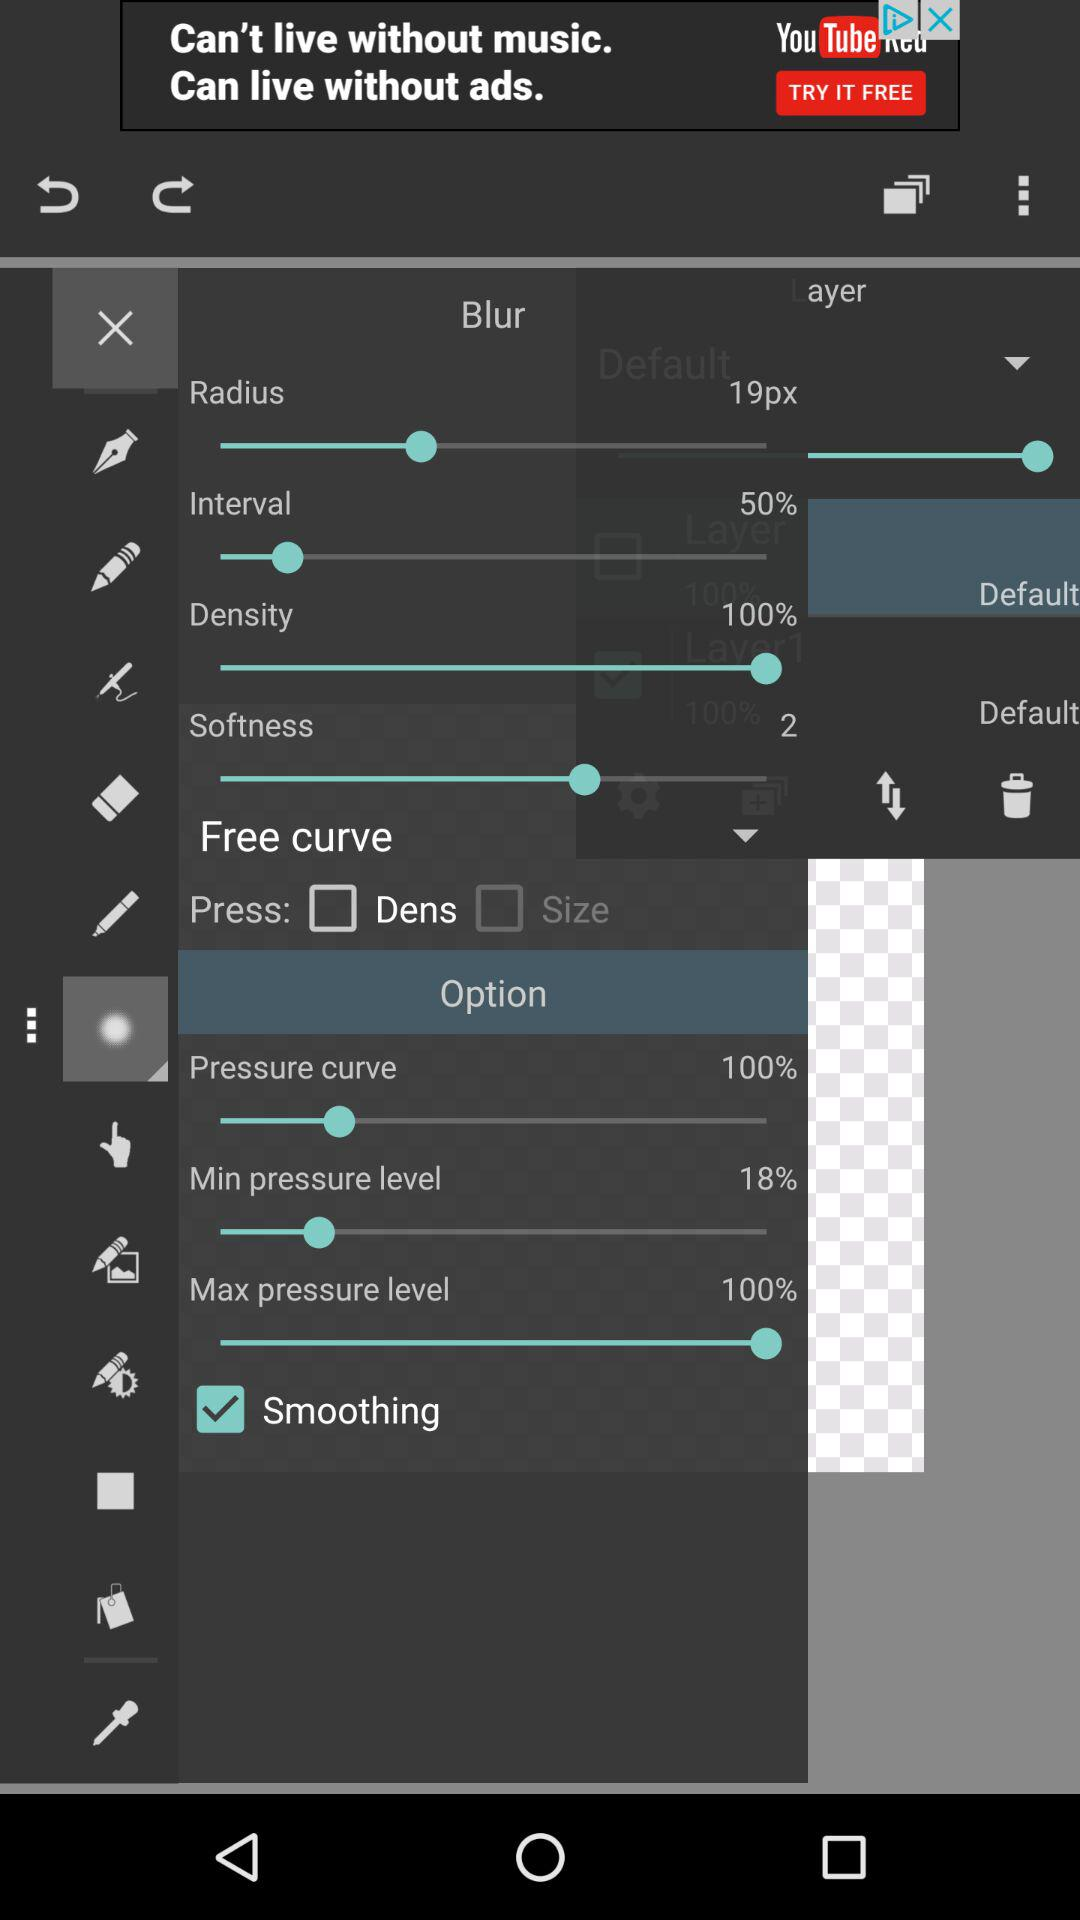What are the given options in "Free curve"? The given options are "Dens" and "Size". 